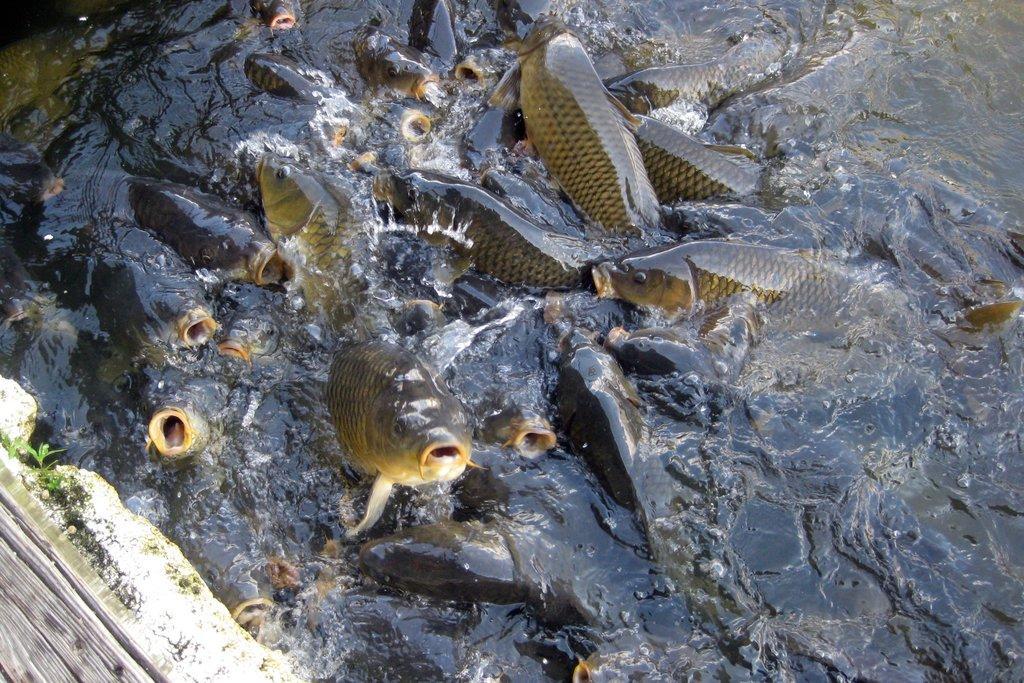How would you summarize this image in a sentence or two? In this picture we can see huge fish are present on the water. In the bottom left corner we can see the wall, plants and log. 